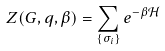<formula> <loc_0><loc_0><loc_500><loc_500>Z ( G , q , \beta ) = \sum _ { \left \{ \sigma _ { i } \right \} } e ^ { - \beta \mathcal { H } }</formula> 